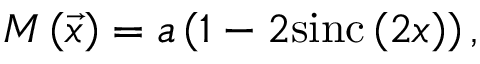Convert formula to latex. <formula><loc_0><loc_0><loc_500><loc_500>M \left ( \vec { x } \right ) = a \left ( 1 - 2 \sin c \left ( 2 x \right ) \right ) ,</formula> 